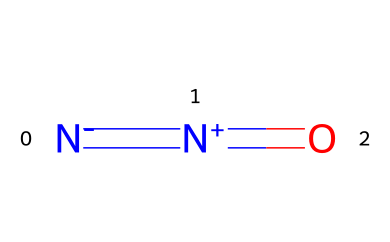What is the common name for N#N=O? The structure depicted shows the elements present are nitrogen and oxygen, which combine to form nitrous oxide, commonly known as laughing gas.
Answer: laughing gas How many nitrogen atoms are in the structure of N#N=O? By analyzing the SMILES representation, we see two 'N' symbols, indicating there are two nitrogen atoms in the structure.
Answer: two What is the type of bond between the nitrogen atoms in N#N=O? The 'N#N' notation in the SMILES indicates a triple bond between the nitrogen atoms, which is a distinct feature of this structure.
Answer: triple bond How many oxygen atoms are present in N#N=O? The SMILES representation shows one 'O' symbol, indicating that there is one oxygen atom in the chemical structure.
Answer: one What is the bond order between nitrogen and oxygen in N#N=O? In the structure, nitrogen is double-bonded to oxygen (as indicated by the '=' symbol), which gives a bond order of 2 between nitrogen and oxygen.
Answer: 2 Is N#N=O a gas at room temperature? Given that nitrous oxide is known to be a gas at room temperature and the structure indicates it belongs to a class of compounds that are typically gaseous under standard conditions, we can confirm its state.
Answer: yes What medical application is primarily associated with N#N=O? Nitrous oxide is primarily used in medical settings as a sedative and analgesic during various procedures, highlighting its importance in healthcare contexts.
Answer: sedation 